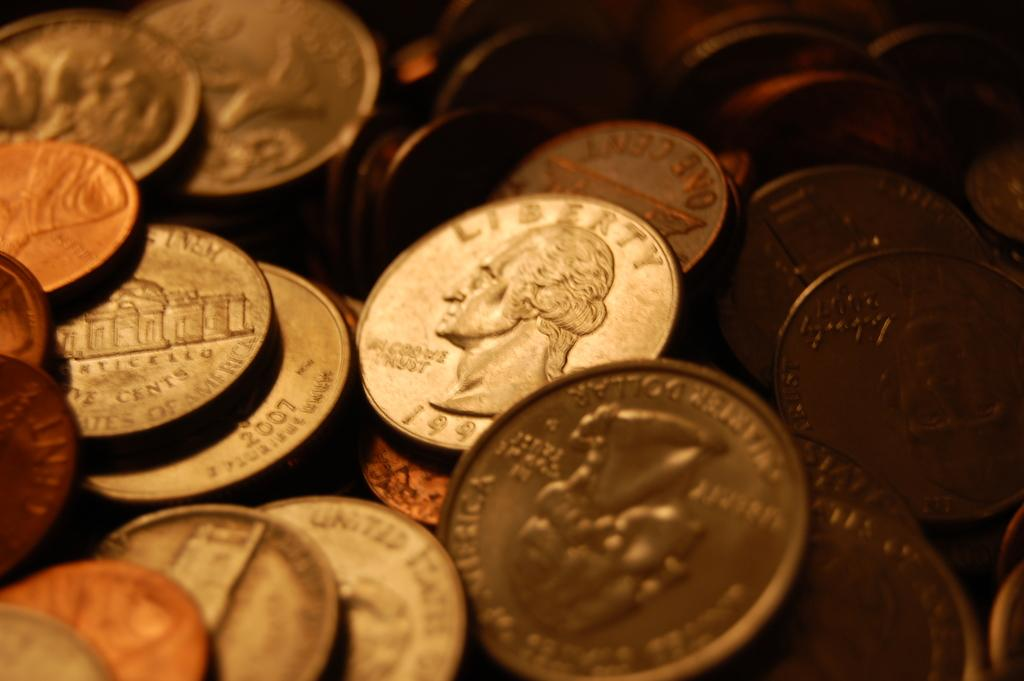<image>
Create a compact narrative representing the image presented. a quarter with the word liberty on the top of it 